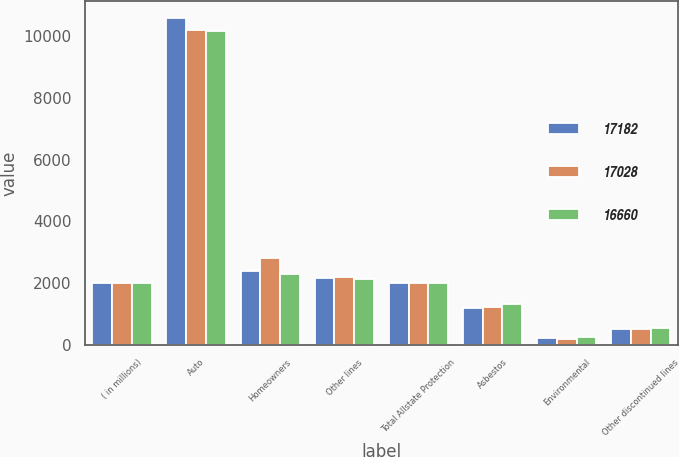Convert chart to OTSL. <chart><loc_0><loc_0><loc_500><loc_500><stacked_bar_chart><ecel><fcel>( in millions)<fcel>Auto<fcel>Homeowners<fcel>Other lines<fcel>Total Allstate Protection<fcel>Asbestos<fcel>Environmental<fcel>Other discontinued lines<nl><fcel>17182<fcel>2009<fcel>10606<fcel>2399<fcel>2145<fcel>2008<fcel>1180<fcel>198<fcel>500<nl><fcel>17028<fcel>2008<fcel>10220<fcel>2824<fcel>2207<fcel>2008<fcel>1228<fcel>195<fcel>508<nl><fcel>16660<fcel>2007<fcel>10175<fcel>2279<fcel>2131<fcel>2008<fcel>1302<fcel>232<fcel>541<nl></chart> 